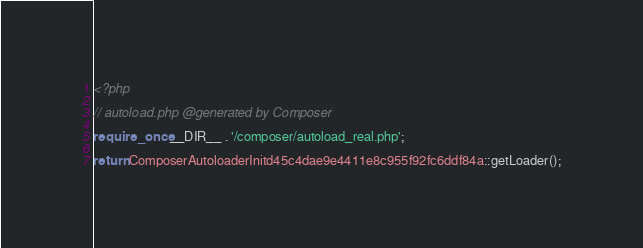Convert code to text. <code><loc_0><loc_0><loc_500><loc_500><_PHP_><?php

// autoload.php @generated by Composer

require_once __DIR__ . '/composer/autoload_real.php';

return ComposerAutoloaderInitd45c4dae9e4411e8c955f92fc6ddf84a::getLoader();
</code> 